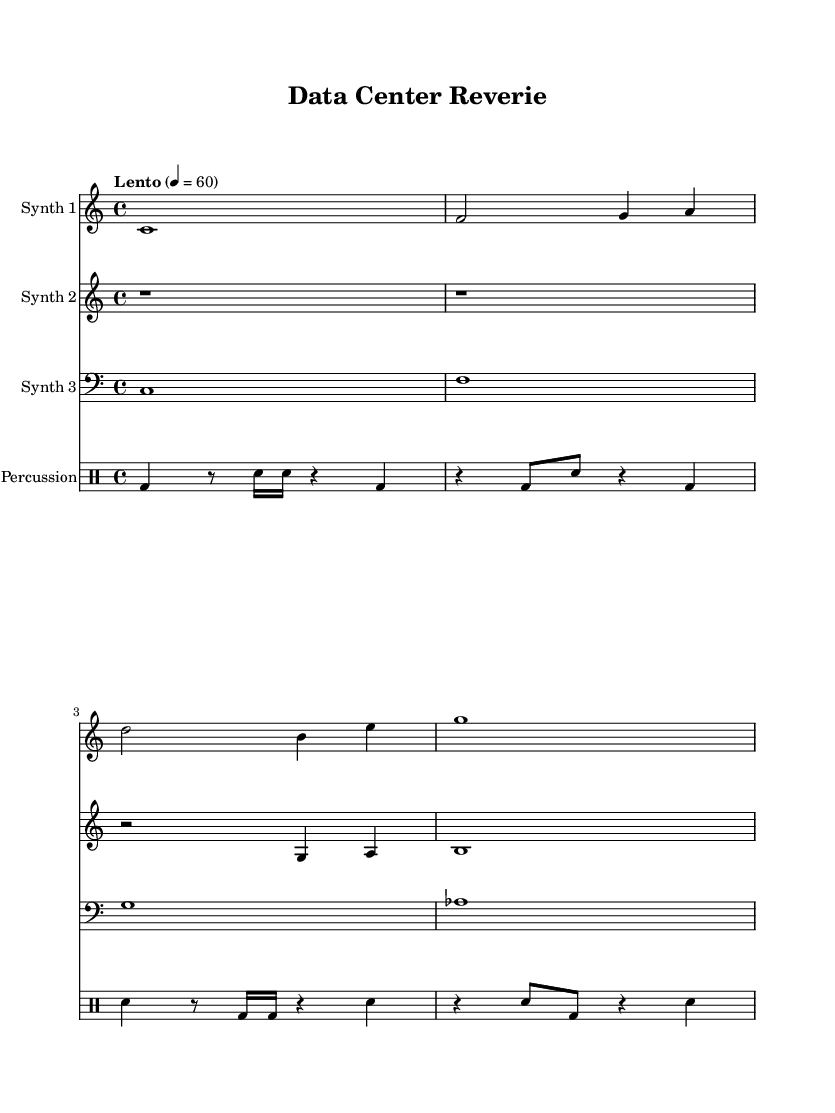What is the time signature of this music? The time signature is indicated at the beginning of the score and is defined by the two numbers stacked vertically. In this case, it shows 4 over 4.
Answer: 4/4 What is the tempo marking for this piece? The tempo marking is specified under the global context of the score. It instructs the performer to play at a slow speed, indicated by "Lento" with a metronome marking of 60 beats per minute.
Answer: Lento 4 = 60 How many different synth parts are there? To determine the number of synth parts, we can count the individual staff sections labeled as "Synth 1", "Synth 2", and "Synth 3" in the score. There are three distinct synth parts.
Answer: 3 What is the highest note played in Synth 1? By examining the notes of Synth 1, we identify that the highest pitch corresponds to the note 'a' in the second measure. It appears above 'g' and below 'b'.
Answer: a What type of rhythm pattern is used in the percussion part? The percussion part can be analyzed by observing its structure, which integrates various note lengths, including bass drums, snares, and rests. The pattern alternates between different rhythms with quarter notes, eighth notes, and sixteenth notes.
Answer: Mixed rhythm pattern What is the clef used for Synth Three? In Synth Three, the clef is indicated at the beginning of the staff. It shows the bass clef, which assigns specific pitches to the notes represented.
Answer: Bass clef What atmosphere does this piece aim to create based on the title? The title "Data Center Reverie" suggests an ambient and contemplative soundscape, likely resembling the sonic environment one might experience in a data center. This is supported by the sustained notes and ethereal qualities of the synths.
Answer: Ambient introspection 